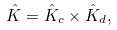Convert formula to latex. <formula><loc_0><loc_0><loc_500><loc_500>\hat { K } = \hat { K } _ { c } \times \hat { K } _ { d } ,</formula> 